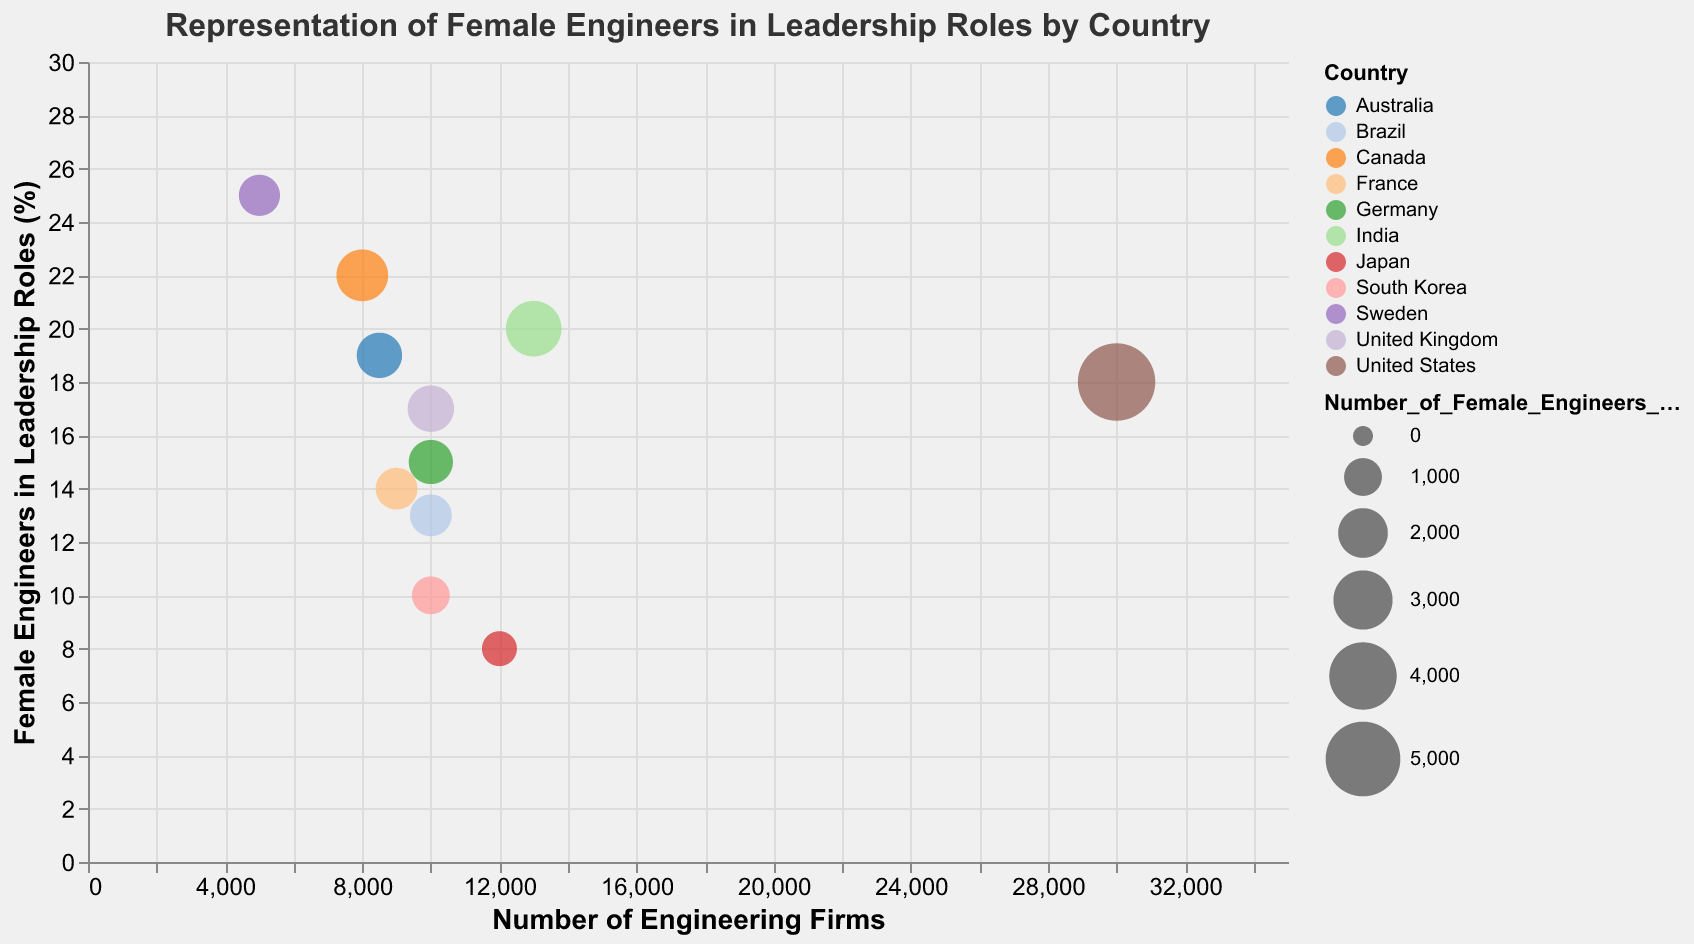Which country has the highest representation of female engineers in leadership roles? The bubble chart indicates the percentage of leadership roles held by female engineers. By inspecting the chart, Sweden has the highest percentage at 25%.
Answer: Sweden Which country has the largest number of engineering firms? The x-axis of the bubble chart represents the number of engineering firms. By observing the chart, the United States has the largest number of engineering firms, 30,000.
Answer: United States How does the representation of female engineers in leadership roles in Canada compare to India? The chart shows the percentage representation. Canada has 22%, while India has 20% representation of female engineers in leadership roles. Therefore, Canada's representation is higher by 2 percentage points.
Answer: Canada’s representation is 2% higher Which country has a higher number of female engineers in leadership, Germany or Australia? The bubble size represents the number of female engineers in leadership roles. Comparing the sizes, Germany has 1,500 and Australia has 1,600. Thus, Australia has a higher number of female engineers in leadership roles.
Answer: Australia What is the total number of engineering firms in Japan and South Korea? The x-axis indicates the number of engineering firms. Japan has 12,000 and South Korea has 10,000. Summing these up, the total is 22,000.
Answer: 22,000 Which country has the smallest bubble size and what does it represent? The smallest bubble represents the number of female engineers in leadership roles, which corresponds to Japan, with 800 female leaders.
Answer: Japan, 800 female leaders Arrange the top three countries by the highest representation of female engineers in leadership roles. By inspecting the chart, the countries with the highest percentage representation are Sweden (25%), Canada (22%), and India (20%).
Answer: Sweden, Canada, India Which country has a similar number of engineering firms but different representation percentages compared to Brazil? Brazil has 10,000 engineering firms. Both Germany and South Korea also have 10,000 firms, but the representation percentages differ: Brazil (13%), Germany (15%), South Korea (10%).
Answer: Germany, South Korea What is the average percentage representation of female engineers in leadership roles for France, Brazil, and South Korea? The percentages are 14% (France), 13% (Brazil), and 10% (South Korea). The average is (14 + 13 + 10) / 3 = 37 / 3 = 12.33%.
Answer: 12.33% Which country has the most engineering firms with less than 20% representation of female engineers in leadership roles? The chart shows the number of engineering firms on the x-axis and representation in percentage on the y-axis. The United States has 30,000 firms and a representation of 18%, fitting the criteria.
Answer: United States 